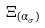Convert formula to latex. <formula><loc_0><loc_0><loc_500><loc_500>\Xi _ { ( \alpha _ { \sigma } ) }</formula> 